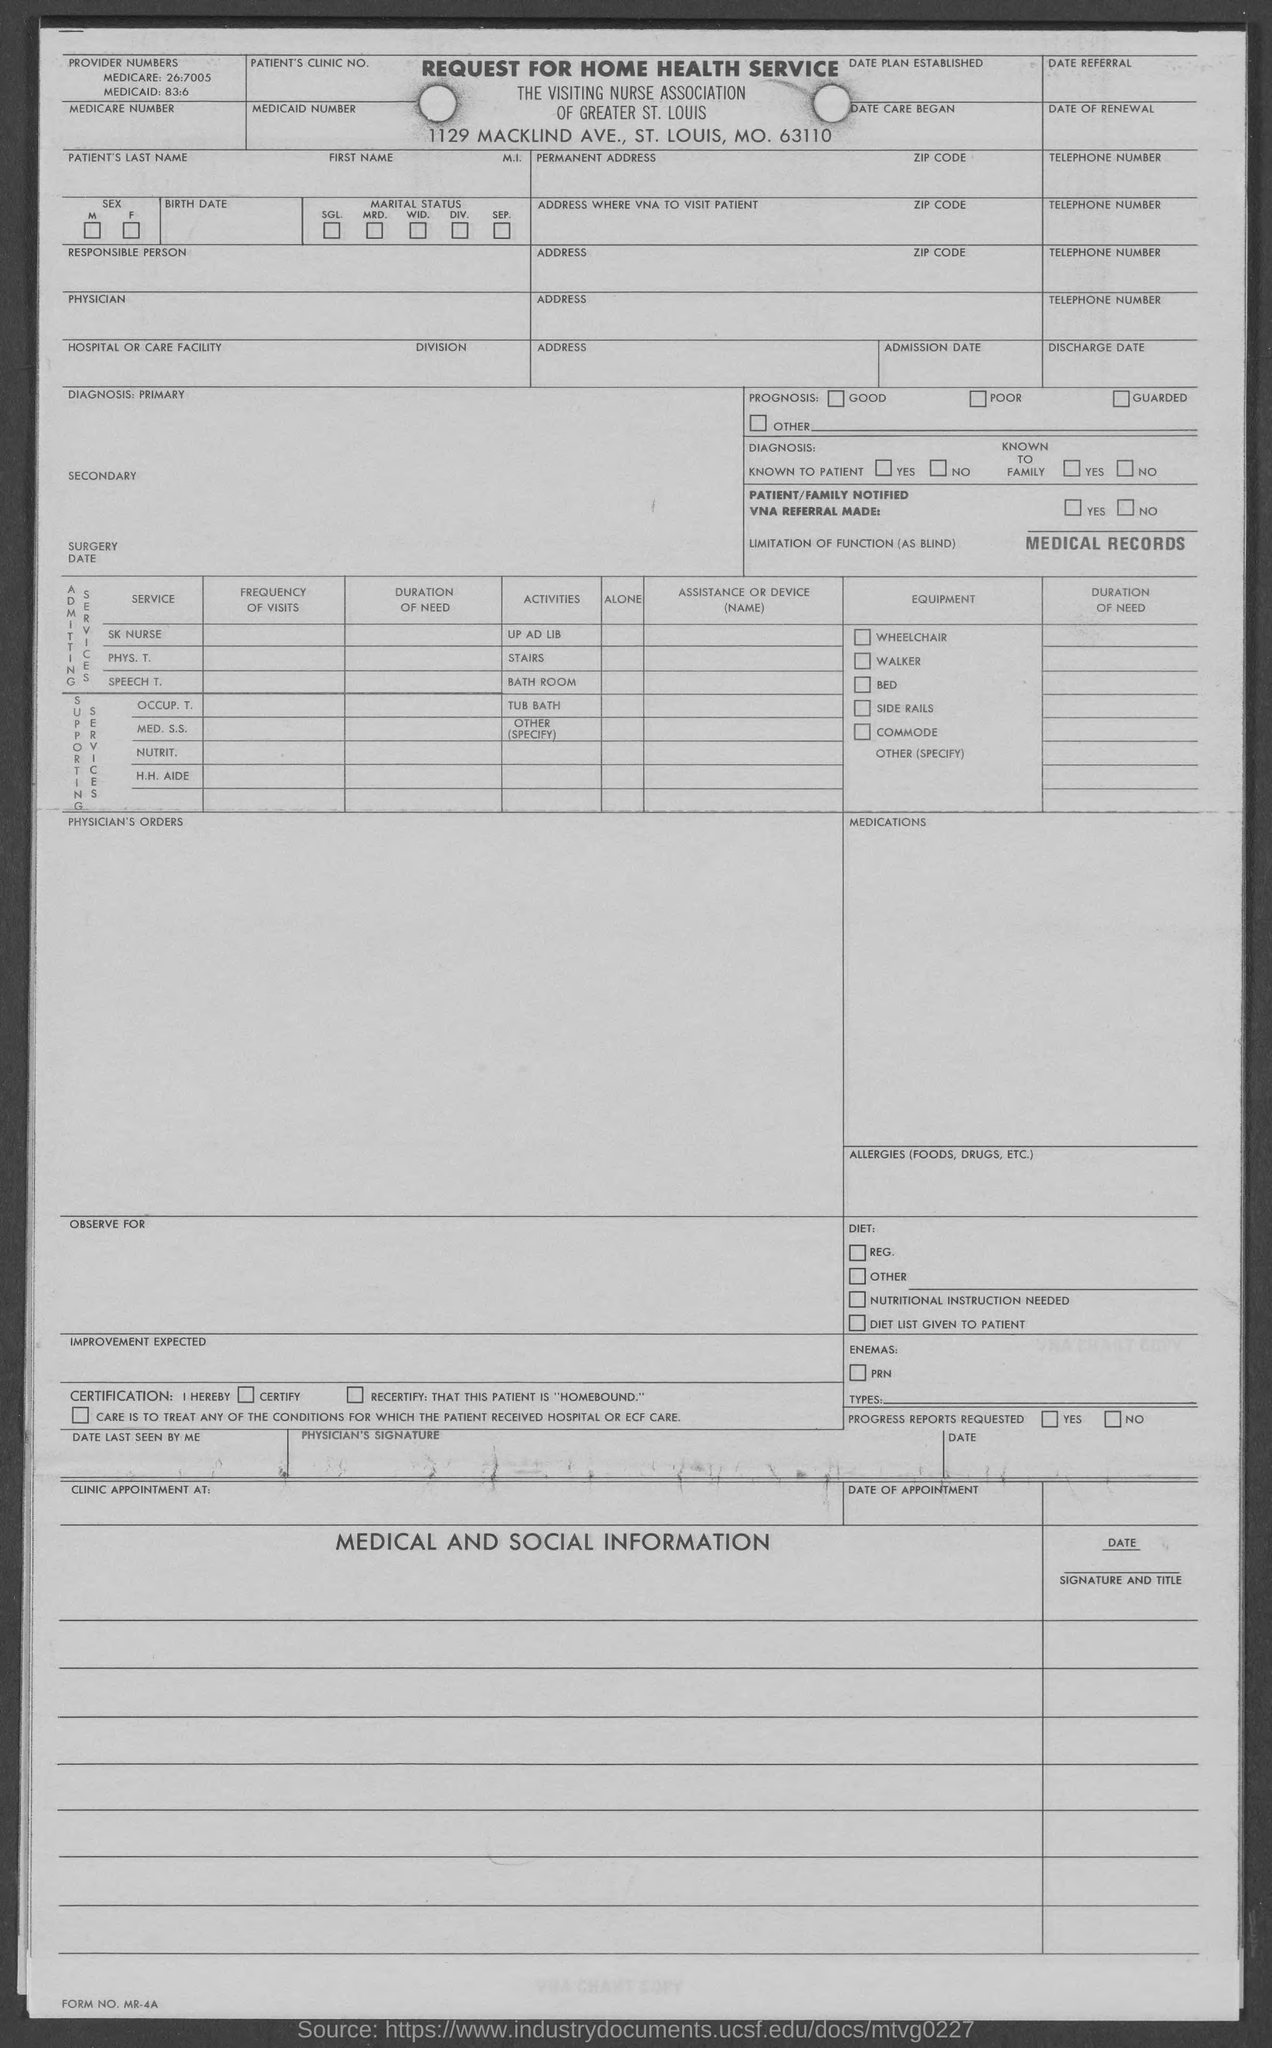What is the provided medicaid number mentioned in the given form ?
Your response must be concise. 83:6. What is the provided medicare number provided in the given form ?
Ensure brevity in your answer.  26:7005. 